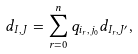<formula> <loc_0><loc_0><loc_500><loc_500>d _ { I , J } = \sum _ { r = 0 } ^ { n } q _ { i _ { r } , j _ { 0 } } d _ { I _ { r } , J ^ { \prime } } ,</formula> 